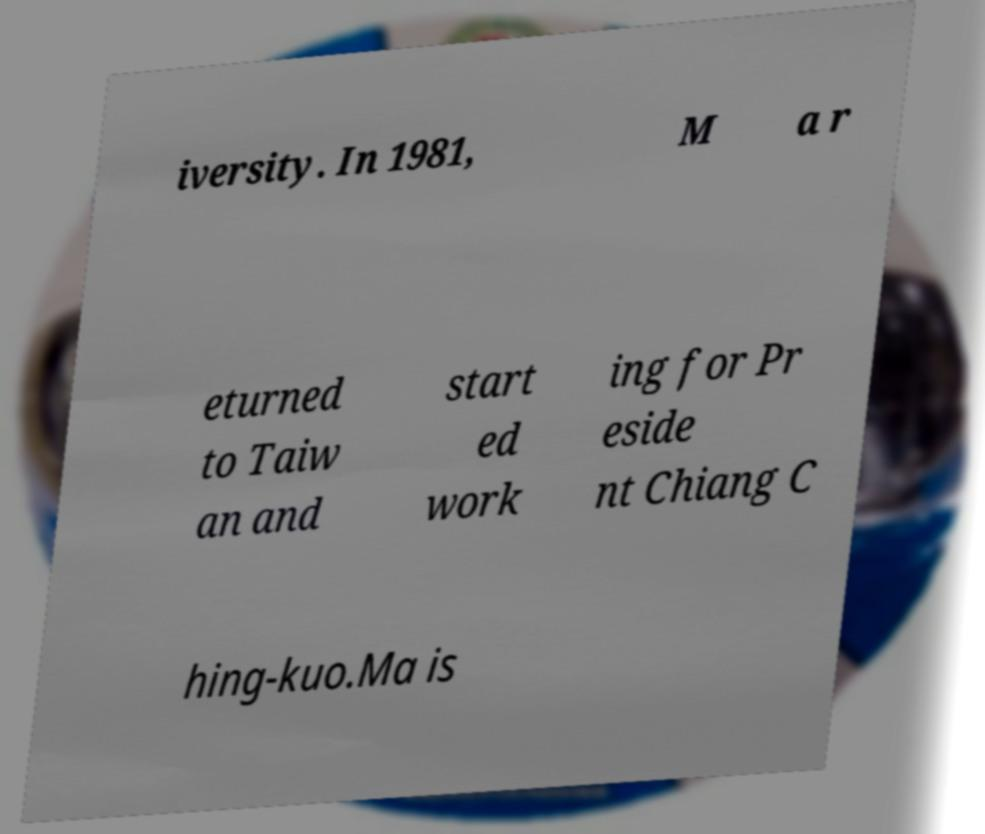For documentation purposes, I need the text within this image transcribed. Could you provide that? iversity. In 1981, M a r eturned to Taiw an and start ed work ing for Pr eside nt Chiang C hing-kuo.Ma is 